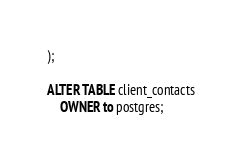Convert code to text. <code><loc_0><loc_0><loc_500><loc_500><_SQL_>);

ALTER TABLE client_contacts
    OWNER to postgres;</code> 